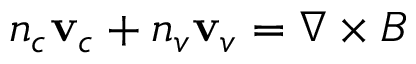<formula> <loc_0><loc_0><loc_500><loc_500>n _ { c } v _ { c } + n _ { v } v _ { v } = \nabla \times B</formula> 